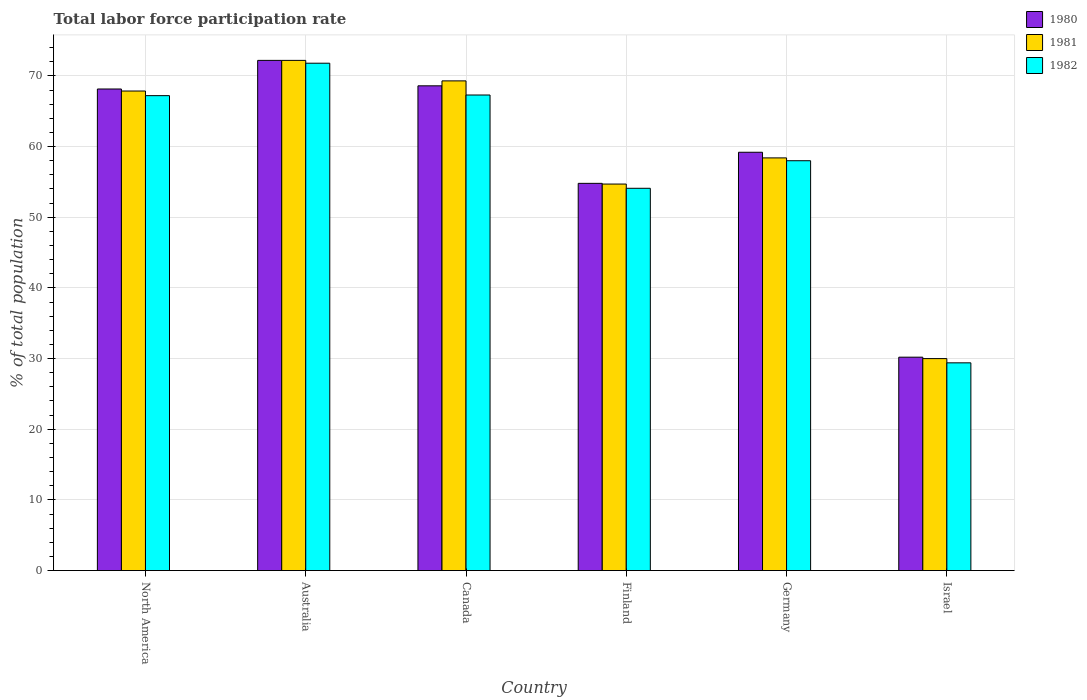How many different coloured bars are there?
Your answer should be very brief. 3. How many groups of bars are there?
Offer a terse response. 6. Are the number of bars per tick equal to the number of legend labels?
Your answer should be compact. Yes. How many bars are there on the 1st tick from the right?
Your answer should be compact. 3. What is the label of the 3rd group of bars from the left?
Offer a terse response. Canada. What is the total labor force participation rate in 1980 in Israel?
Provide a succinct answer. 30.2. Across all countries, what is the maximum total labor force participation rate in 1980?
Your response must be concise. 72.2. In which country was the total labor force participation rate in 1981 minimum?
Your answer should be compact. Israel. What is the total total labor force participation rate in 1982 in the graph?
Keep it short and to the point. 347.81. What is the difference between the total labor force participation rate in 1980 in Finland and that in North America?
Your answer should be very brief. -13.35. What is the difference between the total labor force participation rate in 1981 in North America and the total labor force participation rate in 1982 in Canada?
Ensure brevity in your answer.  0.56. What is the average total labor force participation rate in 1980 per country?
Offer a terse response. 58.86. What is the difference between the total labor force participation rate of/in 1981 and total labor force participation rate of/in 1980 in Finland?
Offer a terse response. -0.1. What is the ratio of the total labor force participation rate in 1981 in Canada to that in Israel?
Provide a succinct answer. 2.31. Is the total labor force participation rate in 1982 in Israel less than that in North America?
Make the answer very short. Yes. What is the difference between the highest and the second highest total labor force participation rate in 1981?
Keep it short and to the point. 4.34. What is the difference between the highest and the lowest total labor force participation rate in 1981?
Offer a very short reply. 42.2. How many bars are there?
Make the answer very short. 18. How many countries are there in the graph?
Your response must be concise. 6. Are the values on the major ticks of Y-axis written in scientific E-notation?
Make the answer very short. No. Does the graph contain any zero values?
Give a very brief answer. No. How are the legend labels stacked?
Offer a terse response. Vertical. What is the title of the graph?
Ensure brevity in your answer.  Total labor force participation rate. Does "1970" appear as one of the legend labels in the graph?
Offer a terse response. No. What is the label or title of the Y-axis?
Keep it short and to the point. % of total population. What is the % of total population in 1980 in North America?
Give a very brief answer. 68.15. What is the % of total population of 1981 in North America?
Make the answer very short. 67.86. What is the % of total population of 1982 in North America?
Offer a very short reply. 67.21. What is the % of total population in 1980 in Australia?
Offer a terse response. 72.2. What is the % of total population in 1981 in Australia?
Offer a very short reply. 72.2. What is the % of total population in 1982 in Australia?
Your answer should be compact. 71.8. What is the % of total population of 1980 in Canada?
Provide a succinct answer. 68.6. What is the % of total population of 1981 in Canada?
Keep it short and to the point. 69.3. What is the % of total population of 1982 in Canada?
Your answer should be very brief. 67.3. What is the % of total population of 1980 in Finland?
Make the answer very short. 54.8. What is the % of total population in 1981 in Finland?
Keep it short and to the point. 54.7. What is the % of total population in 1982 in Finland?
Your answer should be very brief. 54.1. What is the % of total population of 1980 in Germany?
Keep it short and to the point. 59.2. What is the % of total population of 1981 in Germany?
Your response must be concise. 58.4. What is the % of total population in 1982 in Germany?
Offer a terse response. 58. What is the % of total population of 1980 in Israel?
Offer a very short reply. 30.2. What is the % of total population of 1982 in Israel?
Your response must be concise. 29.4. Across all countries, what is the maximum % of total population in 1980?
Offer a very short reply. 72.2. Across all countries, what is the maximum % of total population of 1981?
Your answer should be compact. 72.2. Across all countries, what is the maximum % of total population of 1982?
Provide a short and direct response. 71.8. Across all countries, what is the minimum % of total population in 1980?
Make the answer very short. 30.2. Across all countries, what is the minimum % of total population in 1981?
Your answer should be very brief. 30. Across all countries, what is the minimum % of total population in 1982?
Your answer should be very brief. 29.4. What is the total % of total population of 1980 in the graph?
Offer a very short reply. 353.15. What is the total % of total population of 1981 in the graph?
Your response must be concise. 352.46. What is the total % of total population in 1982 in the graph?
Your response must be concise. 347.81. What is the difference between the % of total population of 1980 in North America and that in Australia?
Offer a terse response. -4.05. What is the difference between the % of total population of 1981 in North America and that in Australia?
Keep it short and to the point. -4.34. What is the difference between the % of total population of 1982 in North America and that in Australia?
Your answer should be very brief. -4.59. What is the difference between the % of total population of 1980 in North America and that in Canada?
Provide a short and direct response. -0.45. What is the difference between the % of total population of 1981 in North America and that in Canada?
Your answer should be compact. -1.44. What is the difference between the % of total population of 1982 in North America and that in Canada?
Make the answer very short. -0.09. What is the difference between the % of total population in 1980 in North America and that in Finland?
Your response must be concise. 13.35. What is the difference between the % of total population of 1981 in North America and that in Finland?
Provide a short and direct response. 13.16. What is the difference between the % of total population of 1982 in North America and that in Finland?
Give a very brief answer. 13.11. What is the difference between the % of total population in 1980 in North America and that in Germany?
Provide a short and direct response. 8.95. What is the difference between the % of total population of 1981 in North America and that in Germany?
Your answer should be very brief. 9.46. What is the difference between the % of total population in 1982 in North America and that in Germany?
Your answer should be very brief. 9.21. What is the difference between the % of total population in 1980 in North America and that in Israel?
Ensure brevity in your answer.  37.95. What is the difference between the % of total population of 1981 in North America and that in Israel?
Provide a succinct answer. 37.86. What is the difference between the % of total population of 1982 in North America and that in Israel?
Make the answer very short. 37.81. What is the difference between the % of total population of 1980 in Australia and that in Canada?
Provide a succinct answer. 3.6. What is the difference between the % of total population in 1982 in Australia and that in Canada?
Keep it short and to the point. 4.5. What is the difference between the % of total population in 1980 in Australia and that in Finland?
Offer a terse response. 17.4. What is the difference between the % of total population in 1981 in Australia and that in Germany?
Your response must be concise. 13.8. What is the difference between the % of total population in 1980 in Australia and that in Israel?
Offer a very short reply. 42. What is the difference between the % of total population in 1981 in Australia and that in Israel?
Give a very brief answer. 42.2. What is the difference between the % of total population in 1982 in Australia and that in Israel?
Ensure brevity in your answer.  42.4. What is the difference between the % of total population of 1982 in Canada and that in Finland?
Make the answer very short. 13.2. What is the difference between the % of total population of 1980 in Canada and that in Germany?
Ensure brevity in your answer.  9.4. What is the difference between the % of total population in 1981 in Canada and that in Germany?
Give a very brief answer. 10.9. What is the difference between the % of total population in 1982 in Canada and that in Germany?
Keep it short and to the point. 9.3. What is the difference between the % of total population of 1980 in Canada and that in Israel?
Give a very brief answer. 38.4. What is the difference between the % of total population in 1981 in Canada and that in Israel?
Offer a very short reply. 39.3. What is the difference between the % of total population of 1982 in Canada and that in Israel?
Your response must be concise. 37.9. What is the difference between the % of total population in 1980 in Finland and that in Germany?
Provide a short and direct response. -4.4. What is the difference between the % of total population of 1980 in Finland and that in Israel?
Make the answer very short. 24.6. What is the difference between the % of total population of 1981 in Finland and that in Israel?
Your response must be concise. 24.7. What is the difference between the % of total population of 1982 in Finland and that in Israel?
Provide a short and direct response. 24.7. What is the difference between the % of total population in 1981 in Germany and that in Israel?
Offer a very short reply. 28.4. What is the difference between the % of total population of 1982 in Germany and that in Israel?
Offer a terse response. 28.6. What is the difference between the % of total population in 1980 in North America and the % of total population in 1981 in Australia?
Provide a succinct answer. -4.05. What is the difference between the % of total population of 1980 in North America and the % of total population of 1982 in Australia?
Your answer should be very brief. -3.65. What is the difference between the % of total population in 1981 in North America and the % of total population in 1982 in Australia?
Your answer should be very brief. -3.94. What is the difference between the % of total population in 1980 in North America and the % of total population in 1981 in Canada?
Your response must be concise. -1.15. What is the difference between the % of total population in 1980 in North America and the % of total population in 1982 in Canada?
Offer a very short reply. 0.85. What is the difference between the % of total population of 1981 in North America and the % of total population of 1982 in Canada?
Your response must be concise. 0.56. What is the difference between the % of total population of 1980 in North America and the % of total population of 1981 in Finland?
Provide a short and direct response. 13.45. What is the difference between the % of total population in 1980 in North America and the % of total population in 1982 in Finland?
Keep it short and to the point. 14.05. What is the difference between the % of total population of 1981 in North America and the % of total population of 1982 in Finland?
Make the answer very short. 13.76. What is the difference between the % of total population in 1980 in North America and the % of total population in 1981 in Germany?
Ensure brevity in your answer.  9.75. What is the difference between the % of total population of 1980 in North America and the % of total population of 1982 in Germany?
Provide a short and direct response. 10.15. What is the difference between the % of total population of 1981 in North America and the % of total population of 1982 in Germany?
Provide a short and direct response. 9.86. What is the difference between the % of total population of 1980 in North America and the % of total population of 1981 in Israel?
Provide a succinct answer. 38.15. What is the difference between the % of total population in 1980 in North America and the % of total population in 1982 in Israel?
Your answer should be compact. 38.75. What is the difference between the % of total population in 1981 in North America and the % of total population in 1982 in Israel?
Your answer should be very brief. 38.46. What is the difference between the % of total population in 1980 in Australia and the % of total population in 1981 in Canada?
Your response must be concise. 2.9. What is the difference between the % of total population of 1980 in Australia and the % of total population of 1982 in Canada?
Your response must be concise. 4.9. What is the difference between the % of total population in 1980 in Australia and the % of total population in 1981 in Finland?
Offer a very short reply. 17.5. What is the difference between the % of total population in 1980 in Australia and the % of total population in 1982 in Finland?
Make the answer very short. 18.1. What is the difference between the % of total population in 1981 in Australia and the % of total population in 1982 in Finland?
Offer a very short reply. 18.1. What is the difference between the % of total population in 1980 in Australia and the % of total population in 1981 in Germany?
Keep it short and to the point. 13.8. What is the difference between the % of total population of 1980 in Australia and the % of total population of 1982 in Germany?
Offer a very short reply. 14.2. What is the difference between the % of total population in 1980 in Australia and the % of total population in 1981 in Israel?
Offer a terse response. 42.2. What is the difference between the % of total population in 1980 in Australia and the % of total population in 1982 in Israel?
Provide a succinct answer. 42.8. What is the difference between the % of total population in 1981 in Australia and the % of total population in 1982 in Israel?
Your response must be concise. 42.8. What is the difference between the % of total population in 1980 in Canada and the % of total population in 1981 in Finland?
Give a very brief answer. 13.9. What is the difference between the % of total population of 1980 in Canada and the % of total population of 1982 in Finland?
Provide a succinct answer. 14.5. What is the difference between the % of total population of 1980 in Canada and the % of total population of 1981 in Germany?
Keep it short and to the point. 10.2. What is the difference between the % of total population of 1980 in Canada and the % of total population of 1981 in Israel?
Keep it short and to the point. 38.6. What is the difference between the % of total population of 1980 in Canada and the % of total population of 1982 in Israel?
Your response must be concise. 39.2. What is the difference between the % of total population of 1981 in Canada and the % of total population of 1982 in Israel?
Your answer should be compact. 39.9. What is the difference between the % of total population of 1980 in Finland and the % of total population of 1981 in Germany?
Your response must be concise. -3.6. What is the difference between the % of total population of 1980 in Finland and the % of total population of 1982 in Germany?
Provide a short and direct response. -3.2. What is the difference between the % of total population of 1980 in Finland and the % of total population of 1981 in Israel?
Your answer should be compact. 24.8. What is the difference between the % of total population of 1980 in Finland and the % of total population of 1982 in Israel?
Your answer should be compact. 25.4. What is the difference between the % of total population of 1981 in Finland and the % of total population of 1982 in Israel?
Keep it short and to the point. 25.3. What is the difference between the % of total population of 1980 in Germany and the % of total population of 1981 in Israel?
Your answer should be compact. 29.2. What is the difference between the % of total population of 1980 in Germany and the % of total population of 1982 in Israel?
Give a very brief answer. 29.8. What is the difference between the % of total population of 1981 in Germany and the % of total population of 1982 in Israel?
Your response must be concise. 29. What is the average % of total population in 1980 per country?
Provide a succinct answer. 58.86. What is the average % of total population in 1981 per country?
Give a very brief answer. 58.74. What is the average % of total population of 1982 per country?
Provide a succinct answer. 57.97. What is the difference between the % of total population in 1980 and % of total population in 1981 in North America?
Your response must be concise. 0.29. What is the difference between the % of total population in 1980 and % of total population in 1982 in North America?
Ensure brevity in your answer.  0.94. What is the difference between the % of total population in 1981 and % of total population in 1982 in North America?
Your answer should be very brief. 0.65. What is the difference between the % of total population in 1980 and % of total population in 1981 in Australia?
Keep it short and to the point. 0. What is the difference between the % of total population of 1981 and % of total population of 1982 in Australia?
Your answer should be very brief. 0.4. What is the difference between the % of total population in 1980 and % of total population in 1981 in Finland?
Provide a succinct answer. 0.1. What is the difference between the % of total population in 1980 and % of total population in 1982 in Finland?
Your answer should be compact. 0.7. What is the difference between the % of total population in 1981 and % of total population in 1982 in Germany?
Your answer should be very brief. 0.4. What is the difference between the % of total population of 1980 and % of total population of 1982 in Israel?
Offer a terse response. 0.8. What is the ratio of the % of total population in 1980 in North America to that in Australia?
Offer a terse response. 0.94. What is the ratio of the % of total population of 1981 in North America to that in Australia?
Provide a short and direct response. 0.94. What is the ratio of the % of total population of 1982 in North America to that in Australia?
Provide a succinct answer. 0.94. What is the ratio of the % of total population in 1980 in North America to that in Canada?
Make the answer very short. 0.99. What is the ratio of the % of total population in 1981 in North America to that in Canada?
Your answer should be very brief. 0.98. What is the ratio of the % of total population of 1980 in North America to that in Finland?
Offer a very short reply. 1.24. What is the ratio of the % of total population of 1981 in North America to that in Finland?
Keep it short and to the point. 1.24. What is the ratio of the % of total population in 1982 in North America to that in Finland?
Provide a succinct answer. 1.24. What is the ratio of the % of total population of 1980 in North America to that in Germany?
Keep it short and to the point. 1.15. What is the ratio of the % of total population of 1981 in North America to that in Germany?
Your response must be concise. 1.16. What is the ratio of the % of total population in 1982 in North America to that in Germany?
Offer a very short reply. 1.16. What is the ratio of the % of total population in 1980 in North America to that in Israel?
Give a very brief answer. 2.26. What is the ratio of the % of total population of 1981 in North America to that in Israel?
Ensure brevity in your answer.  2.26. What is the ratio of the % of total population in 1982 in North America to that in Israel?
Make the answer very short. 2.29. What is the ratio of the % of total population in 1980 in Australia to that in Canada?
Keep it short and to the point. 1.05. What is the ratio of the % of total population in 1981 in Australia to that in Canada?
Your response must be concise. 1.04. What is the ratio of the % of total population in 1982 in Australia to that in Canada?
Provide a succinct answer. 1.07. What is the ratio of the % of total population in 1980 in Australia to that in Finland?
Provide a short and direct response. 1.32. What is the ratio of the % of total population of 1981 in Australia to that in Finland?
Provide a succinct answer. 1.32. What is the ratio of the % of total population in 1982 in Australia to that in Finland?
Your answer should be compact. 1.33. What is the ratio of the % of total population of 1980 in Australia to that in Germany?
Provide a succinct answer. 1.22. What is the ratio of the % of total population in 1981 in Australia to that in Germany?
Your response must be concise. 1.24. What is the ratio of the % of total population of 1982 in Australia to that in Germany?
Your answer should be compact. 1.24. What is the ratio of the % of total population in 1980 in Australia to that in Israel?
Offer a terse response. 2.39. What is the ratio of the % of total population of 1981 in Australia to that in Israel?
Offer a very short reply. 2.41. What is the ratio of the % of total population in 1982 in Australia to that in Israel?
Your response must be concise. 2.44. What is the ratio of the % of total population of 1980 in Canada to that in Finland?
Your answer should be very brief. 1.25. What is the ratio of the % of total population in 1981 in Canada to that in Finland?
Provide a succinct answer. 1.27. What is the ratio of the % of total population of 1982 in Canada to that in Finland?
Ensure brevity in your answer.  1.24. What is the ratio of the % of total population of 1980 in Canada to that in Germany?
Offer a terse response. 1.16. What is the ratio of the % of total population in 1981 in Canada to that in Germany?
Provide a succinct answer. 1.19. What is the ratio of the % of total population of 1982 in Canada to that in Germany?
Offer a very short reply. 1.16. What is the ratio of the % of total population of 1980 in Canada to that in Israel?
Your response must be concise. 2.27. What is the ratio of the % of total population of 1981 in Canada to that in Israel?
Your answer should be very brief. 2.31. What is the ratio of the % of total population in 1982 in Canada to that in Israel?
Give a very brief answer. 2.29. What is the ratio of the % of total population of 1980 in Finland to that in Germany?
Offer a terse response. 0.93. What is the ratio of the % of total population in 1981 in Finland to that in Germany?
Your response must be concise. 0.94. What is the ratio of the % of total population of 1982 in Finland to that in Germany?
Make the answer very short. 0.93. What is the ratio of the % of total population in 1980 in Finland to that in Israel?
Provide a succinct answer. 1.81. What is the ratio of the % of total population of 1981 in Finland to that in Israel?
Keep it short and to the point. 1.82. What is the ratio of the % of total population in 1982 in Finland to that in Israel?
Provide a succinct answer. 1.84. What is the ratio of the % of total population of 1980 in Germany to that in Israel?
Ensure brevity in your answer.  1.96. What is the ratio of the % of total population in 1981 in Germany to that in Israel?
Provide a short and direct response. 1.95. What is the ratio of the % of total population in 1982 in Germany to that in Israel?
Your answer should be very brief. 1.97. What is the difference between the highest and the second highest % of total population of 1981?
Offer a terse response. 2.9. What is the difference between the highest and the second highest % of total population of 1982?
Give a very brief answer. 4.5. What is the difference between the highest and the lowest % of total population of 1981?
Your answer should be compact. 42.2. What is the difference between the highest and the lowest % of total population of 1982?
Your answer should be very brief. 42.4. 